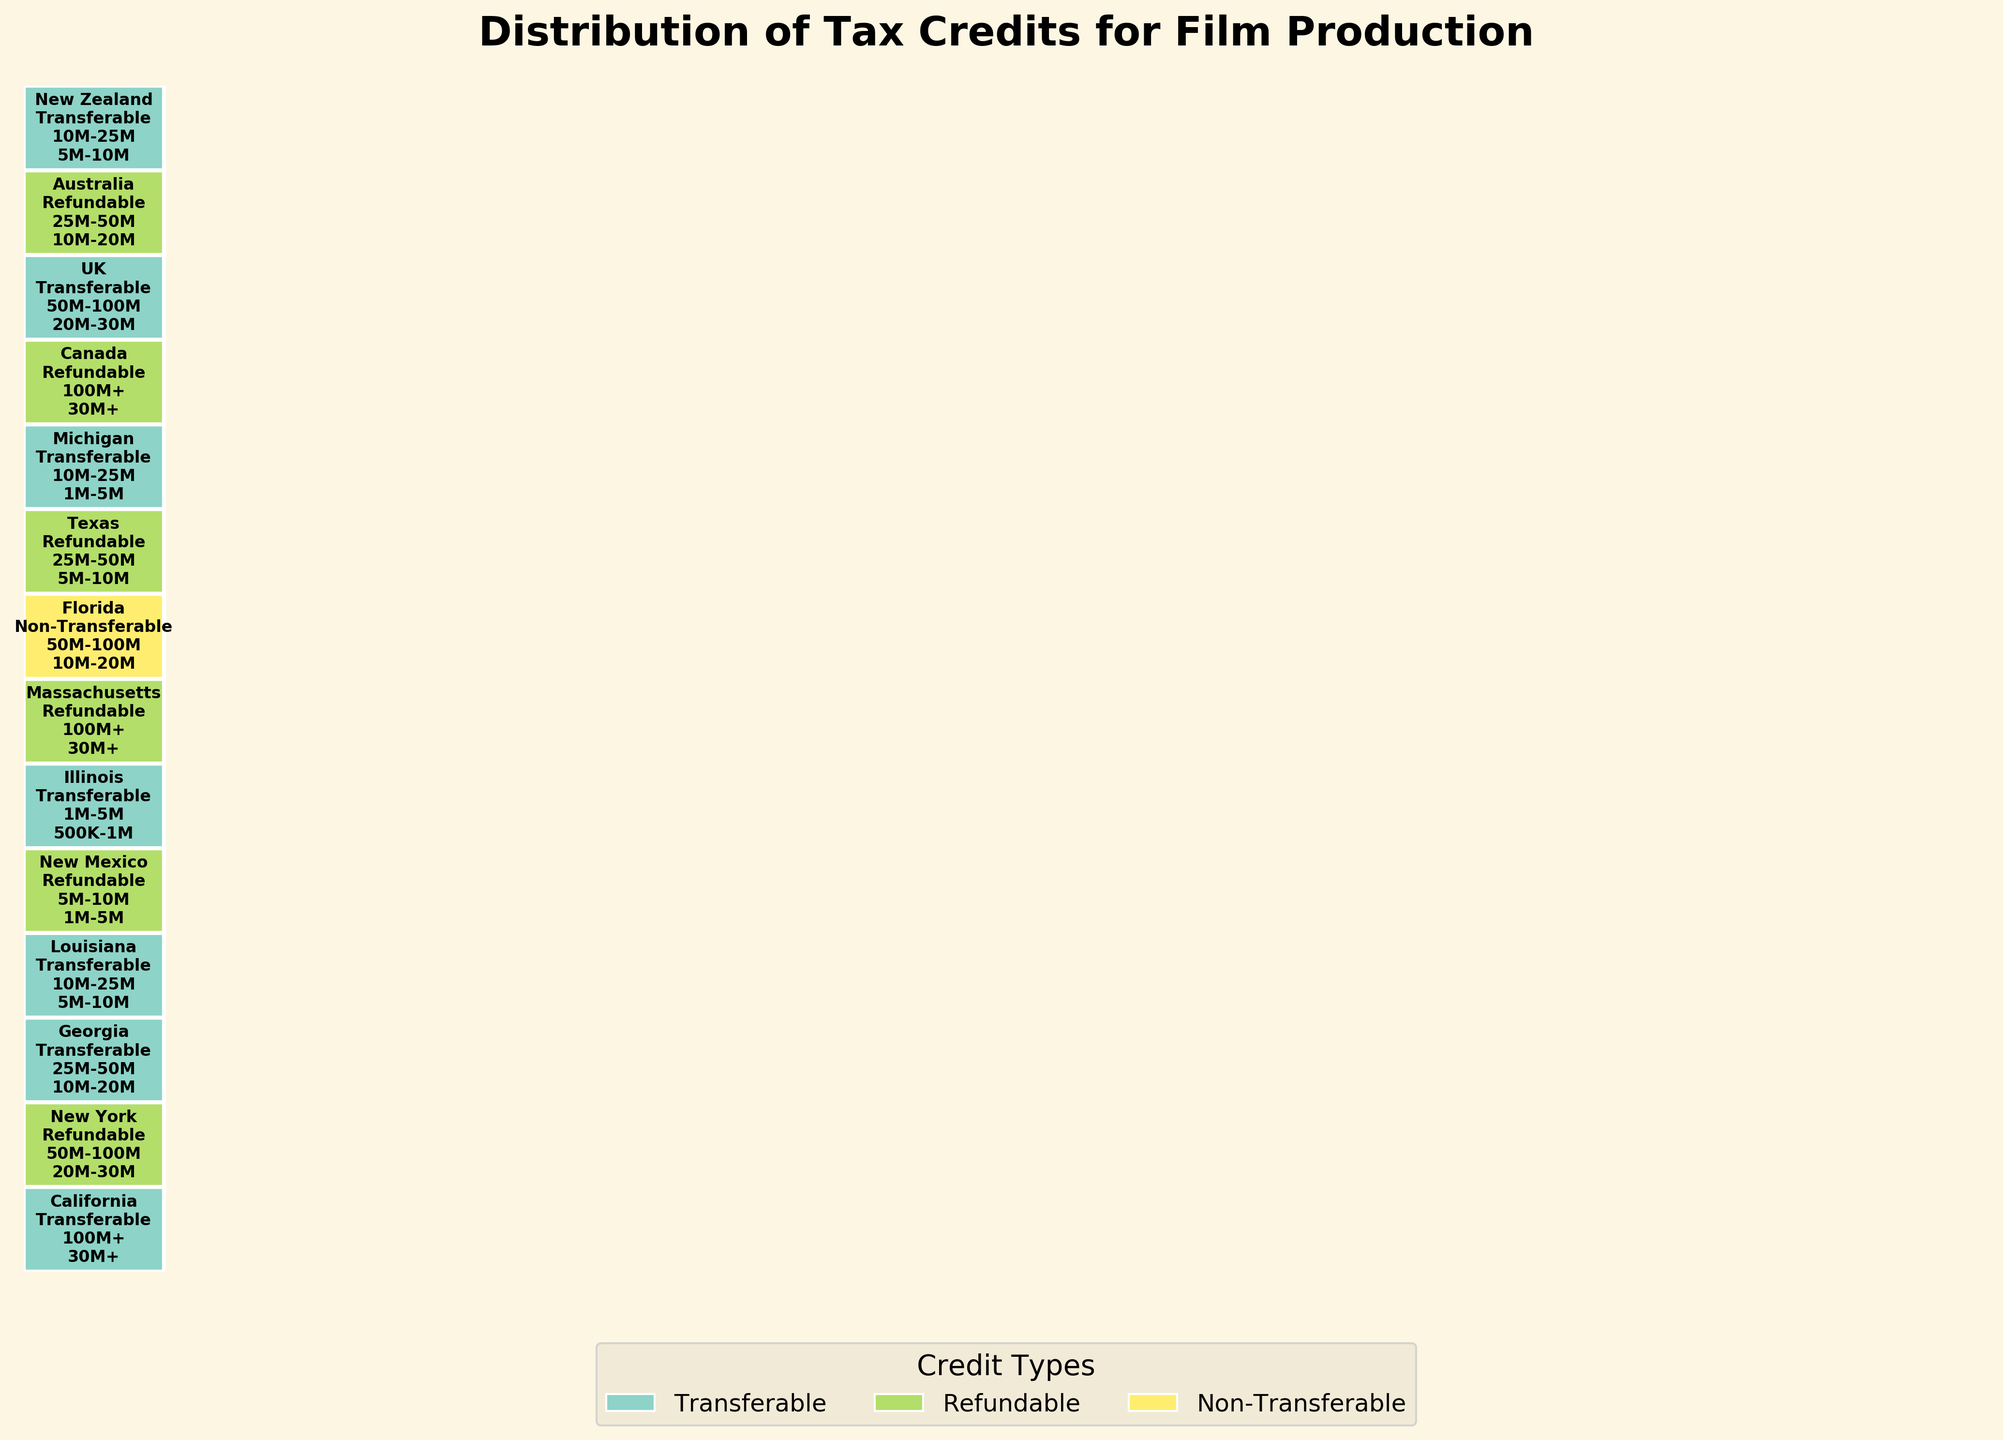what is the title of the plot? The title of a plot gives a summary of what the visual representation is about. In this case, the title is displayed at the top center of the plot.
Answer: Distribution of Tax Credits for Film Production How many credit types are represented in the plot? To determine the number of credit types, you can look at the legend below the plot, which shows different credit types and their associated colors. By counting the unique credit types in the legend, we find: Transferable, Refundable, and Non-Transferable.
Answer: 3 Which state has the highest credit amount in the Refundable category? The 'Refundable' category is marked with a specific color. By scanning through the plot, the highest credit amounts can be identified through text labels inside the rectangles. Massachusetts and Canada both show the highest amount (30M+).
Answer: Massachusetts and Canada What is the range of production budgets for Texas? Locate Texas in the 'Refundable' credit type section, the associated production budget value is displayed inside the rectangle for Texas.
Answer: 25M-50M Which states or countries are missing the ‘Refundable’ credit type? By looking at the legend and then verifying against the states/boxes in the plot, the states with no 'Refundable' credit type are observed. These include California, Georgia, Louisiana, Illinois, Florida, Michigan, UK, and New Zealand.
Answer: California, Georgia, Louisiana, Illinois, Florida, Michigan, UK, New Zealand Which state offers the lowest credit amount for a ‘Transferable’ credit type, and what is that amount? Examine the states within the 'Transferable' section. By comparing the credit amounts stated inside the rectangles, Illinois shows the lowest credit amount (500K-1M).
Answer: Illinois, 500K-1M Calculate the combined production budget range for all states offering the 'Refundable' credit type. Sum up the production budget ranges for states offering 'Refundable' credit type: New York (50M-100M), New Mexico (5M-10M), Massachusetts (100M+), Texas (25M-50M), Canada (100M+), and Australia (25M-50M). The combined range is calculated as the minimum from the lowest boundary to the maximum from the highest boundary.
Answer: 5M-100M+ Which country has similar tax credits to those offered by New Zealand, based on production budget and credit amounts? Identify the characteristics for New Zealand (10M-25M budget, 5M-10M credit) and check other states/countries with similar attributes. Louisiana has similar characteristics.
Answer: Louisiana 